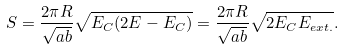<formula> <loc_0><loc_0><loc_500><loc_500>S = \frac { 2 \pi R } { \sqrt { a b } } \sqrt { E _ { C } ( 2 E - E _ { C } ) } = \frac { 2 \pi R } { \sqrt { a b } } \sqrt { 2 E _ { C } E _ { e x t . } } .</formula> 